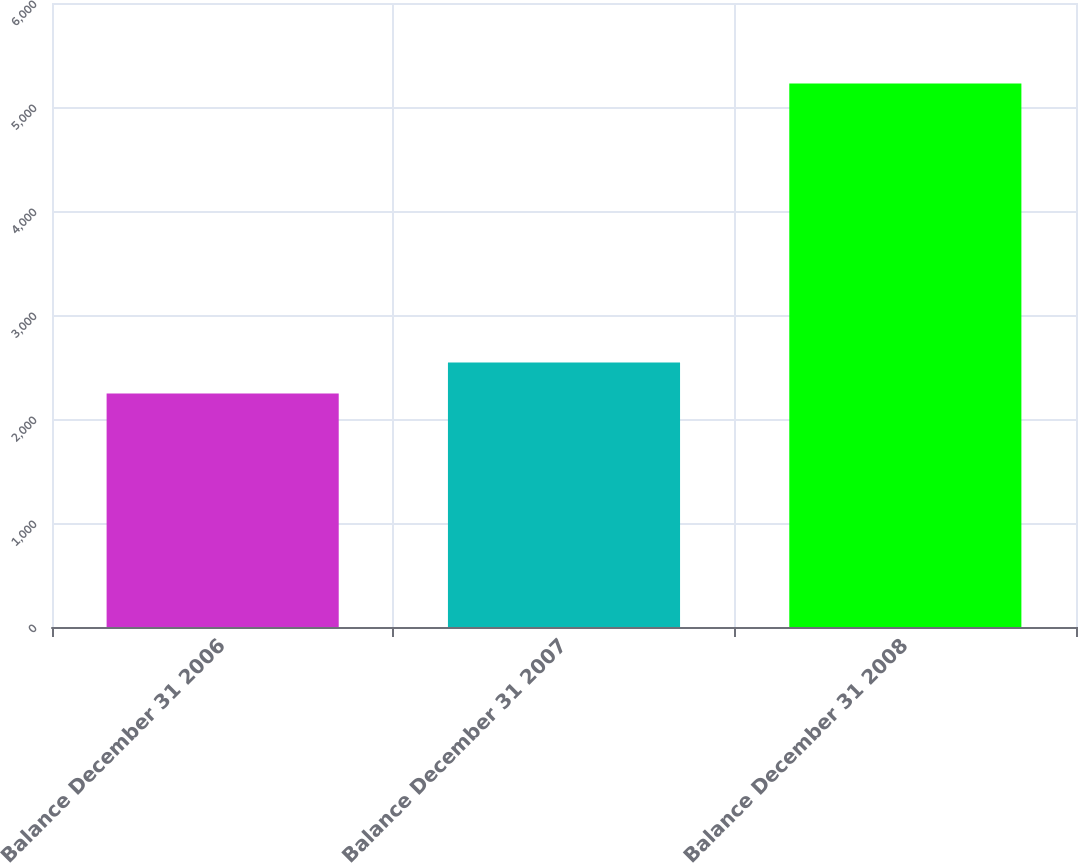<chart> <loc_0><loc_0><loc_500><loc_500><bar_chart><fcel>Balance December 31 2006<fcel>Balance December 31 2007<fcel>Balance December 31 2008<nl><fcel>2244.7<fcel>2542.73<fcel>5225<nl></chart> 